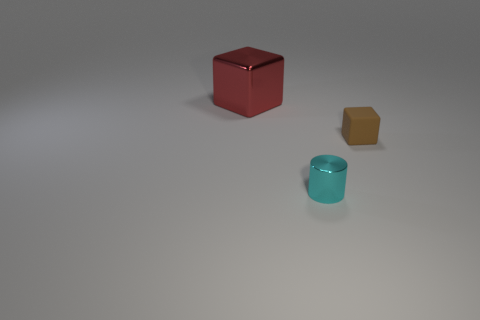Do the red cube and the small cyan cylinder in front of the tiny cube have the same material?
Make the answer very short. Yes. What number of other red cubes have the same size as the metallic cube?
Your response must be concise. 0. Is the number of large red metal things right of the brown block less than the number of red cylinders?
Provide a succinct answer. No. How many metal objects are in front of the big thing?
Offer a terse response. 1. What is the size of the object in front of the small thing that is right of the small object in front of the small brown thing?
Ensure brevity in your answer.  Small. Do the cyan shiny thing and the small thing that is right of the cyan shiny object have the same shape?
Give a very brief answer. No. There is a thing that is the same material as the big block; what is its size?
Give a very brief answer. Small. Are there any other things that have the same color as the tiny cube?
Provide a short and direct response. No. What is the object behind the cube right of the cube that is on the left side of the cyan cylinder made of?
Provide a short and direct response. Metal. How many metal objects are either tiny cyan cubes or big cubes?
Offer a terse response. 1. 